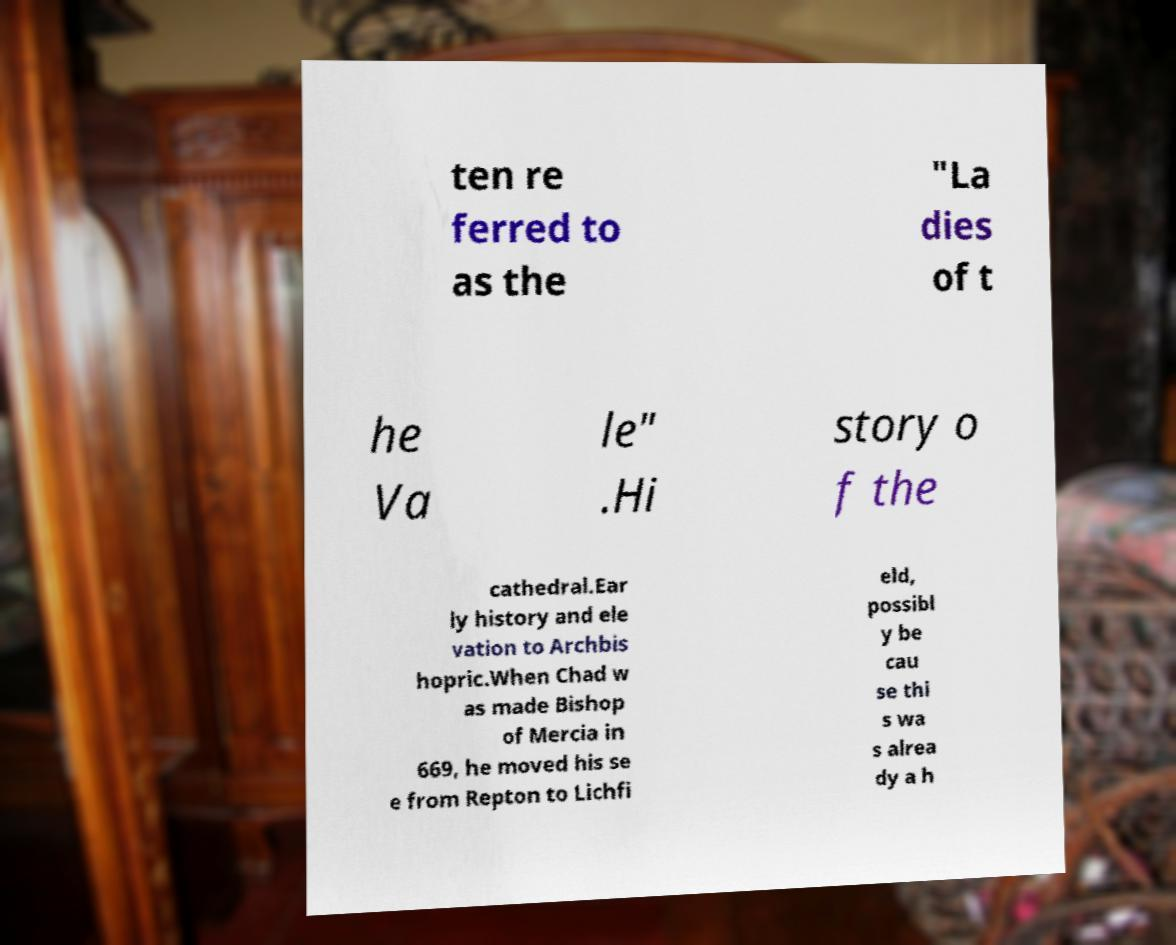Can you read and provide the text displayed in the image?This photo seems to have some interesting text. Can you extract and type it out for me? ten re ferred to as the "La dies of t he Va le" .Hi story o f the cathedral.Ear ly history and ele vation to Archbis hopric.When Chad w as made Bishop of Mercia in 669, he moved his se e from Repton to Lichfi eld, possibl y be cau se thi s wa s alrea dy a h 